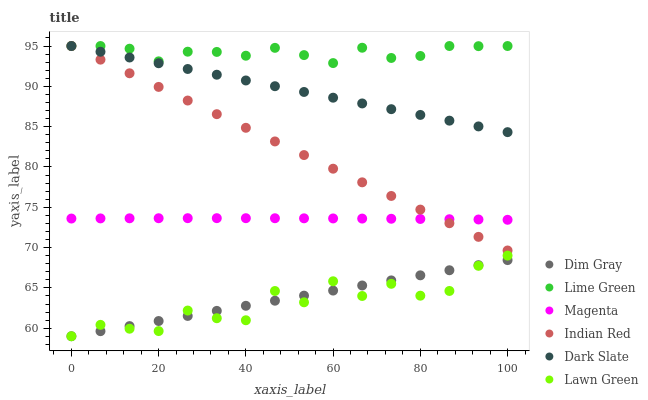Does Lawn Green have the minimum area under the curve?
Answer yes or no. Yes. Does Lime Green have the maximum area under the curve?
Answer yes or no. Yes. Does Dim Gray have the minimum area under the curve?
Answer yes or no. No. Does Dim Gray have the maximum area under the curve?
Answer yes or no. No. Is Indian Red the smoothest?
Answer yes or no. Yes. Is Lawn Green the roughest?
Answer yes or no. Yes. Is Dim Gray the smoothest?
Answer yes or no. No. Is Dim Gray the roughest?
Answer yes or no. No. Does Lawn Green have the lowest value?
Answer yes or no. Yes. Does Dark Slate have the lowest value?
Answer yes or no. No. Does Lime Green have the highest value?
Answer yes or no. Yes. Does Dim Gray have the highest value?
Answer yes or no. No. Is Magenta less than Dark Slate?
Answer yes or no. Yes. Is Indian Red greater than Dim Gray?
Answer yes or no. Yes. Does Indian Red intersect Magenta?
Answer yes or no. Yes. Is Indian Red less than Magenta?
Answer yes or no. No. Is Indian Red greater than Magenta?
Answer yes or no. No. Does Magenta intersect Dark Slate?
Answer yes or no. No. 